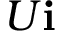<formula> <loc_0><loc_0><loc_500><loc_500>U { i }</formula> 